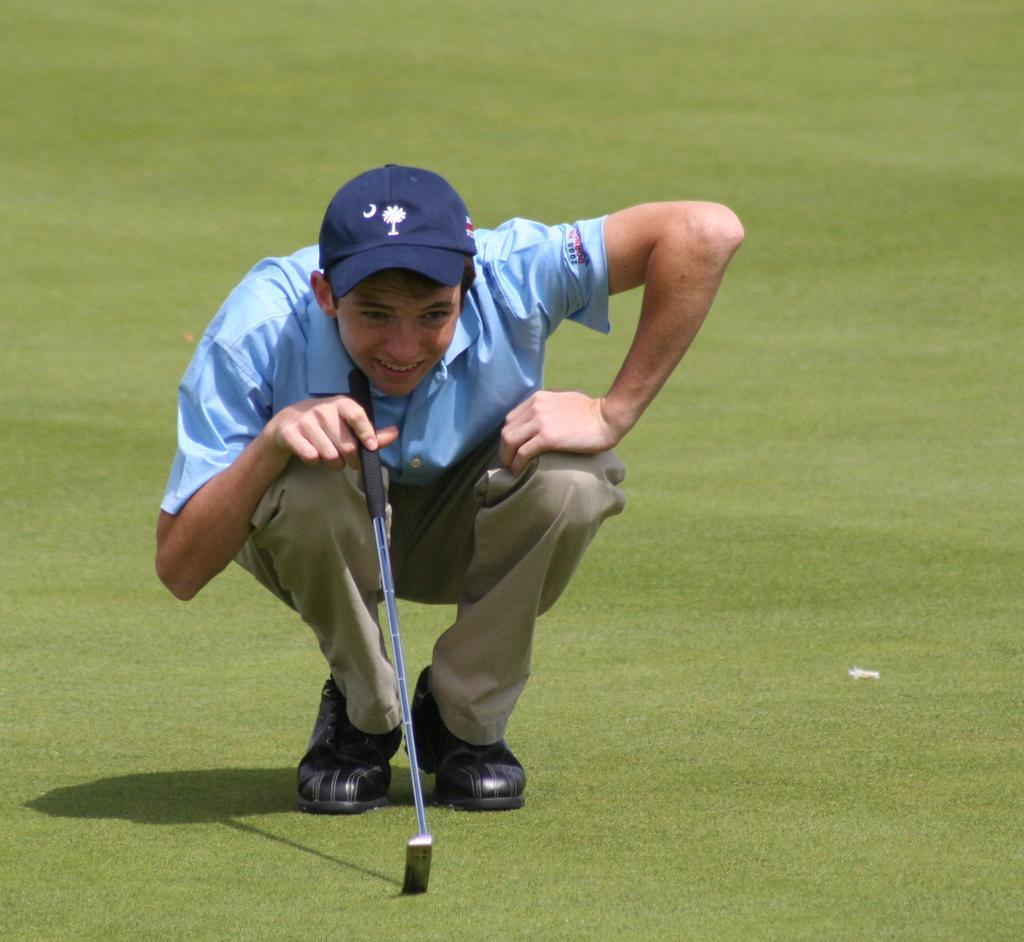How would you summarize this image in a sentence or two? In this picture we can see a man wore cap, shoes and holding a stick with his hand and in the background we can see grass. 